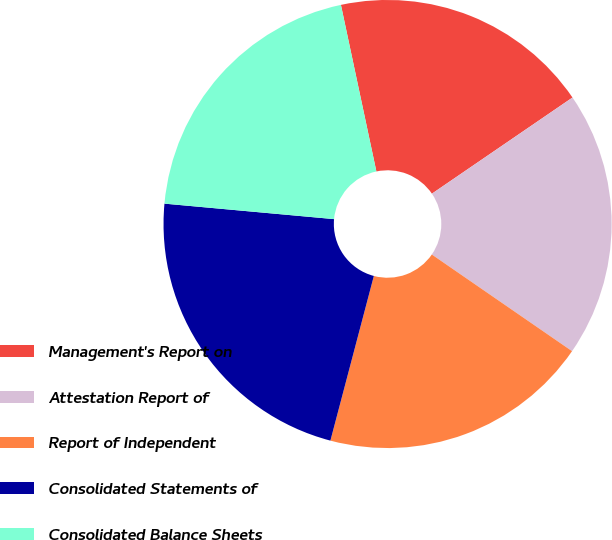Convert chart to OTSL. <chart><loc_0><loc_0><loc_500><loc_500><pie_chart><fcel>Management's Report on<fcel>Attestation Report of<fcel>Report of Independent<fcel>Consolidated Statements of<fcel>Consolidated Balance Sheets<nl><fcel>18.79%<fcel>19.15%<fcel>19.5%<fcel>22.34%<fcel>20.21%<nl></chart> 